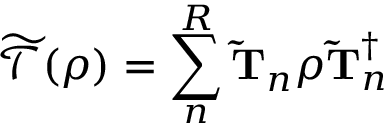Convert formula to latex. <formula><loc_0><loc_0><loc_500><loc_500>\mathcal { \widetilde { T } } ( \rho ) = \sum _ { n } ^ { R } \widetilde { T } _ { n } \rho \widetilde { T } _ { n } ^ { \dagger }</formula> 